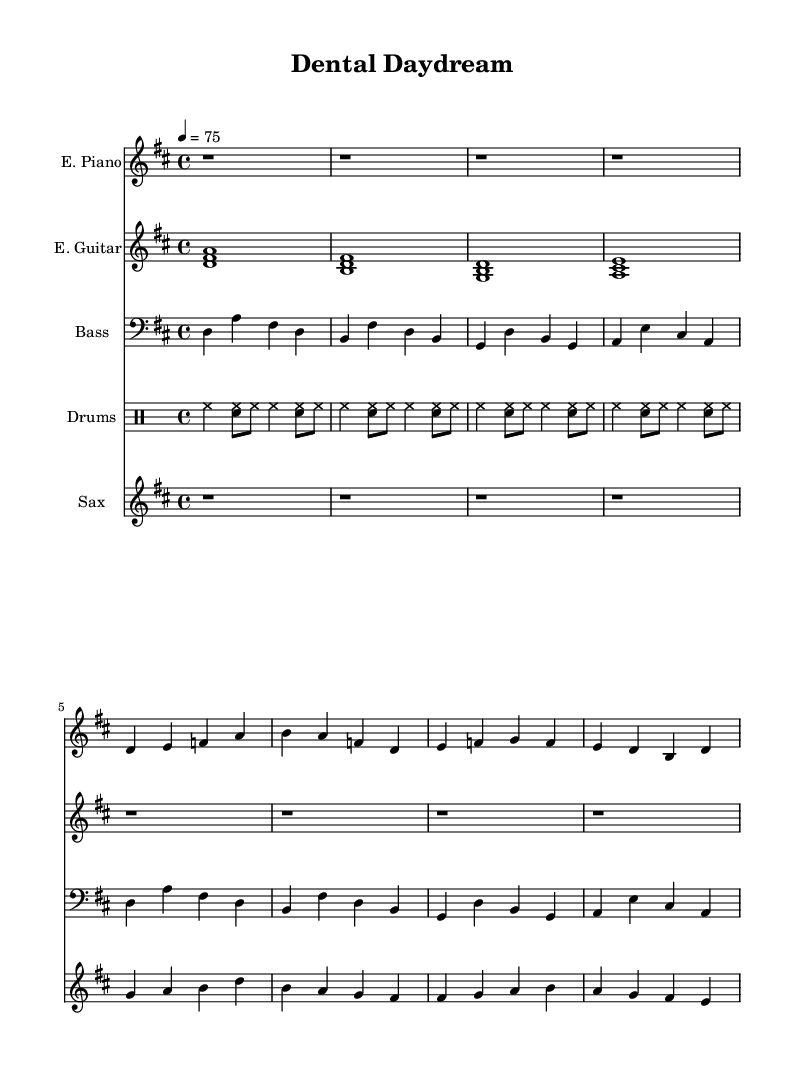What is the key signature of this music? The key signature is indicated with sharps or flats at the beginning of the staff. In this case, it shows two sharps, indicating D major.
Answer: D major What is the time signature of this music? The time signature is found at the beginning of the staff; it shows 4 over 4, meaning there are four beats per measure and a quarter note gets one beat.
Answer: 4/4 What is the tempo marking of this piece? The tempo marking is shown at the beginning of the music with a number and equals sign; here, it is 4 = 75, indicating a tempo of 75 beats per minute.
Answer: 75 How many measures are there in the electric piano part? By counting the bars in the electric piano part, there are a total of 8 measures visible, each representing a group of beats.
Answer: 8 Which instrument plays the main melody in the first section? The main melody is typically played by the instrument that has the most prominent line; in this case, the saxophone plays the main melody.
Answer: Saxophone What type of harmony is typically found in smooth jazz-rock fusion? Smooth jazz-rock fusion often utilizes extended chords and complex harmonies like 7th and 9th chords, which provide a rich and colorful sound.
Answer: Extended chords How do the drums contribute to the feel of this piece? The drum part, characterized by a steady hi-hat and snare combination, provides a rhythmic cushion and maintains the groove essential for fusion music.
Answer: Steady rhythm 